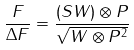<formula> <loc_0><loc_0><loc_500><loc_500>\frac { F } { \Delta F } = \frac { ( S W ) \otimes P } { \sqrt { W \otimes P ^ { 2 } } }</formula> 